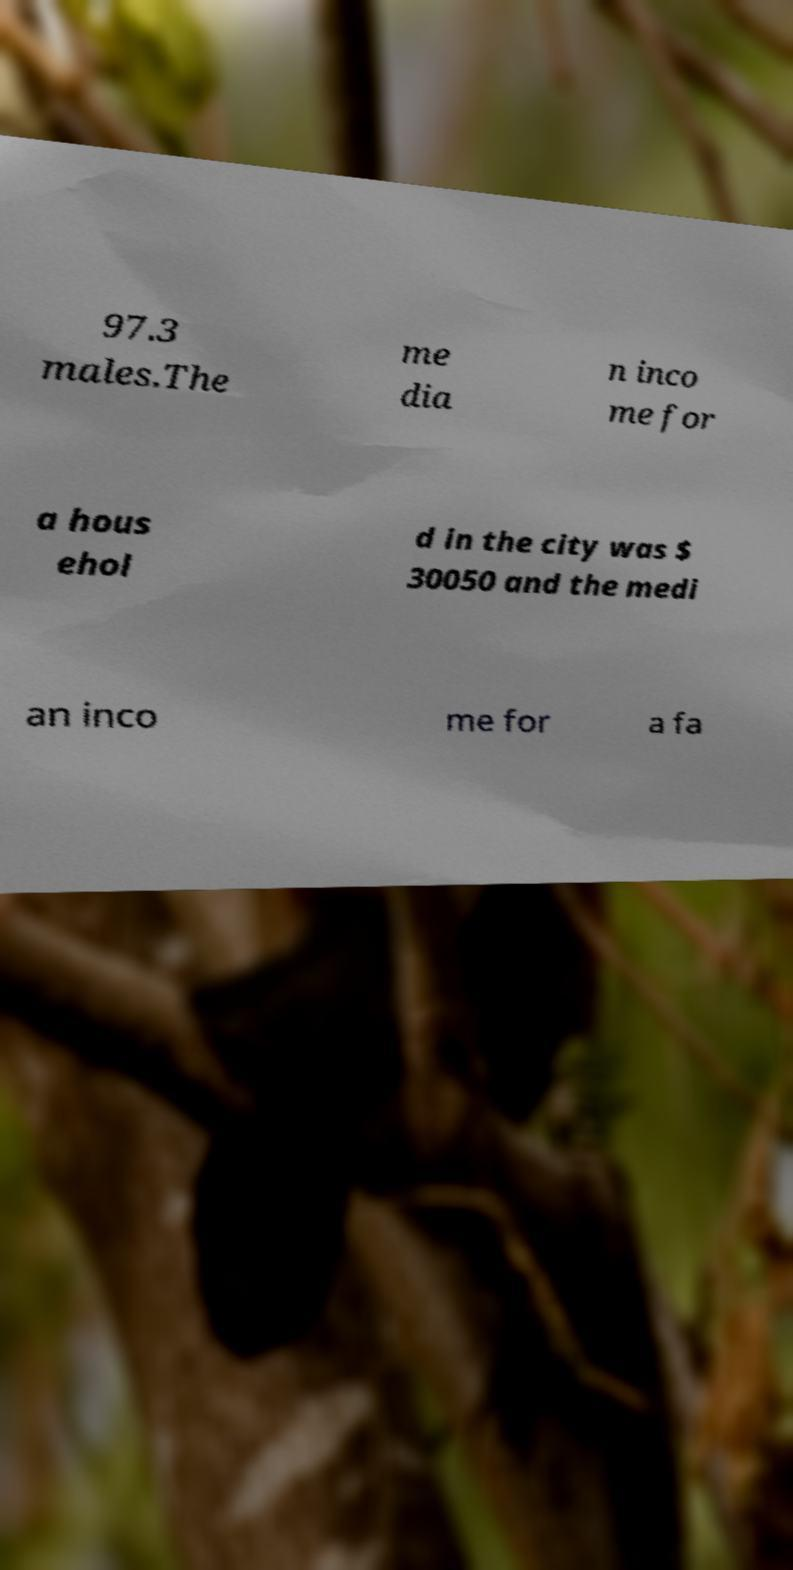Can you accurately transcribe the text from the provided image for me? 97.3 males.The me dia n inco me for a hous ehol d in the city was $ 30050 and the medi an inco me for a fa 